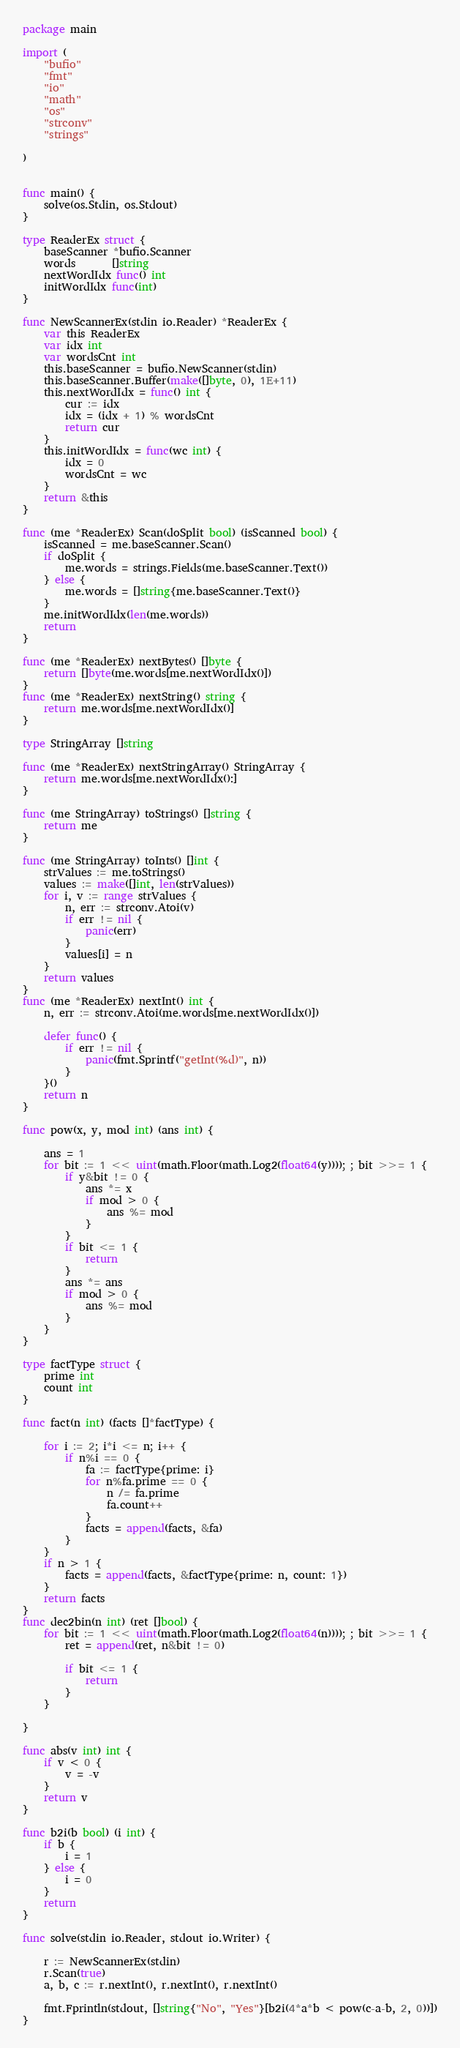<code> <loc_0><loc_0><loc_500><loc_500><_Go_>package main

import (
	"bufio"
	"fmt"
	"io"
	"math"
	"os"
	"strconv"
	"strings"

)


func main() {
	solve(os.Stdin, os.Stdout)
}

type ReaderEx struct {
	baseScanner *bufio.Scanner
	words       []string
	nextWordIdx func() int
	initWordIdx func(int)
}

func NewScannerEx(stdin io.Reader) *ReaderEx {
	var this ReaderEx
	var idx int
	var wordsCnt int
	this.baseScanner = bufio.NewScanner(stdin)
	this.baseScanner.Buffer(make([]byte, 0), 1E+11)
	this.nextWordIdx = func() int {
		cur := idx
		idx = (idx + 1) % wordsCnt
		return cur
	}
	this.initWordIdx = func(wc int) {
		idx = 0
		wordsCnt = wc
	}
	return &this
}

func (me *ReaderEx) Scan(doSplit bool) (isScanned bool) {
	isScanned = me.baseScanner.Scan()
	if doSplit {
		me.words = strings.Fields(me.baseScanner.Text())
	} else {
		me.words = []string{me.baseScanner.Text()}
	}
	me.initWordIdx(len(me.words))
	return
}

func (me *ReaderEx) nextBytes() []byte {
	return []byte(me.words[me.nextWordIdx()])
}
func (me *ReaderEx) nextString() string {
	return me.words[me.nextWordIdx()]
}

type StringArray []string

func (me *ReaderEx) nextStringArray() StringArray {
	return me.words[me.nextWordIdx():]
}

func (me StringArray) toStrings() []string {
	return me
}

func (me StringArray) toInts() []int {
	strValues := me.toStrings()
	values := make([]int, len(strValues))
	for i, v := range strValues {
		n, err := strconv.Atoi(v)
		if err != nil {
			panic(err)
		}
		values[i] = n
	}
	return values
}
func (me *ReaderEx) nextInt() int {
	n, err := strconv.Atoi(me.words[me.nextWordIdx()])

	defer func() {
		if err != nil {
			panic(fmt.Sprintf("getInt(%d)", n))
		}
	}()
	return n
}

func pow(x, y, mod int) (ans int) {

	ans = 1
	for bit := 1 << uint(math.Floor(math.Log2(float64(y)))); ; bit >>= 1 {
		if y&bit != 0 {
			ans *= x
			if mod > 0 {
				ans %= mod
			}
		}
		if bit <= 1 {
			return
		}
		ans *= ans
		if mod > 0 {
			ans %= mod
		}
	}
}

type factType struct {
	prime int
	count int
}

func fact(n int) (facts []*factType) {

	for i := 2; i*i <= n; i++ {
		if n%i == 0 {
			fa := factType{prime: i}
			for n%fa.prime == 0 {
				n /= fa.prime
				fa.count++
			}
			facts = append(facts, &fa)
		}
	}
	if n > 1 {
		facts = append(facts, &factType{prime: n, count: 1})
	}
	return facts
}
func dec2bin(n int) (ret []bool) {
	for bit := 1 << uint(math.Floor(math.Log2(float64(n)))); ; bit >>= 1 {
		ret = append(ret, n&bit != 0)

		if bit <= 1 {
			return
		}
	}

}

func abs(v int) int {
	if v < 0 {
		v = -v
	}
	return v
}

func b2i(b bool) (i int) {
	if b {
		i = 1
	} else {
		i = 0
	}
	return
}

func solve(stdin io.Reader, stdout io.Writer) {

	r := NewScannerEx(stdin)
	r.Scan(true)
	a, b, c := r.nextInt(), r.nextInt(), r.nextInt()

	fmt.Fprintln(stdout, []string{"No", "Yes"}[b2i(4*a*b < pow(c-a-b, 2, 0))])
}
</code> 